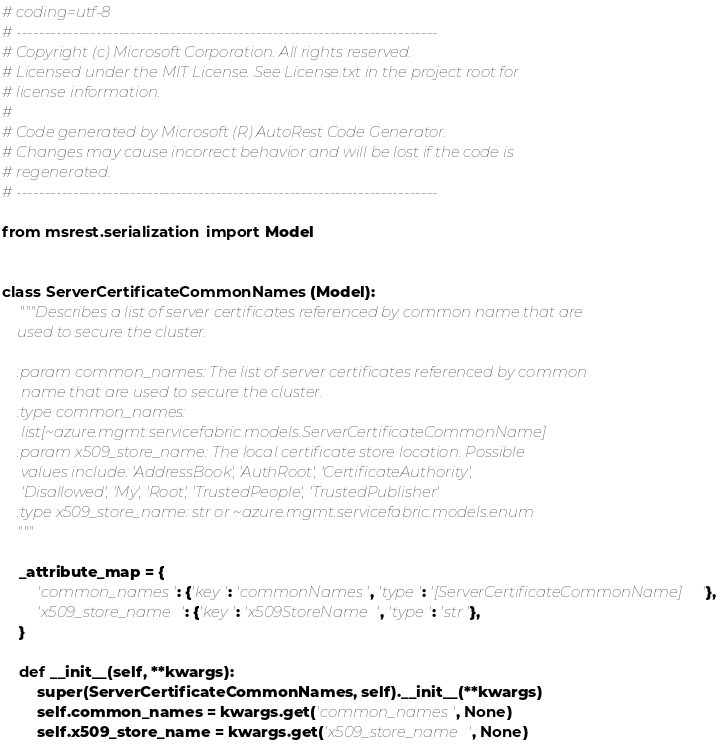Convert code to text. <code><loc_0><loc_0><loc_500><loc_500><_Python_># coding=utf-8
# --------------------------------------------------------------------------
# Copyright (c) Microsoft Corporation. All rights reserved.
# Licensed under the MIT License. See License.txt in the project root for
# license information.
#
# Code generated by Microsoft (R) AutoRest Code Generator.
# Changes may cause incorrect behavior and will be lost if the code is
# regenerated.
# --------------------------------------------------------------------------

from msrest.serialization import Model


class ServerCertificateCommonNames(Model):
    """Describes a list of server certificates referenced by common name that are
    used to secure the cluster.

    :param common_names: The list of server certificates referenced by common
     name that are used to secure the cluster.
    :type common_names:
     list[~azure.mgmt.servicefabric.models.ServerCertificateCommonName]
    :param x509_store_name: The local certificate store location. Possible
     values include: 'AddressBook', 'AuthRoot', 'CertificateAuthority',
     'Disallowed', 'My', 'Root', 'TrustedPeople', 'TrustedPublisher'
    :type x509_store_name: str or ~azure.mgmt.servicefabric.models.enum
    """

    _attribute_map = {
        'common_names': {'key': 'commonNames', 'type': '[ServerCertificateCommonName]'},
        'x509_store_name': {'key': 'x509StoreName', 'type': 'str'},
    }

    def __init__(self, **kwargs):
        super(ServerCertificateCommonNames, self).__init__(**kwargs)
        self.common_names = kwargs.get('common_names', None)
        self.x509_store_name = kwargs.get('x509_store_name', None)
</code> 